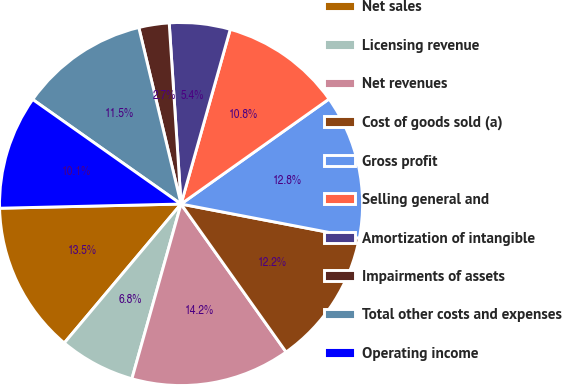Convert chart to OTSL. <chart><loc_0><loc_0><loc_500><loc_500><pie_chart><fcel>Net sales<fcel>Licensing revenue<fcel>Net revenues<fcel>Cost of goods sold (a)<fcel>Gross profit<fcel>Selling general and<fcel>Amortization of intangible<fcel>Impairments of assets<fcel>Total other costs and expenses<fcel>Operating income<nl><fcel>13.51%<fcel>6.76%<fcel>14.19%<fcel>12.16%<fcel>12.84%<fcel>10.81%<fcel>5.41%<fcel>2.7%<fcel>11.49%<fcel>10.14%<nl></chart> 